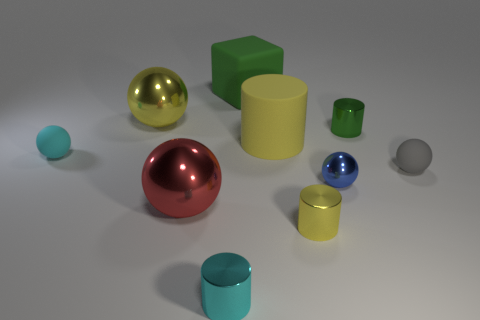How many other things are the same material as the small blue object?
Ensure brevity in your answer.  5. Does the large rubber cylinder have the same color as the rubber block?
Provide a succinct answer. No. Are there fewer yellow matte cylinders that are on the left side of the big yellow matte cylinder than cyan things that are behind the small cyan metallic cylinder?
Your response must be concise. Yes. What color is the other matte thing that is the same shape as the small green object?
Provide a succinct answer. Yellow. Do the matte ball that is right of the blue ball and the tiny yellow object have the same size?
Your response must be concise. Yes. Is the number of big green things that are in front of the large red sphere less than the number of green cubes?
Your answer should be very brief. Yes. What size is the shiny thing behind the tiny green metal thing behind the tiny yellow cylinder?
Ensure brevity in your answer.  Large. Is there anything else that has the same shape as the blue metal thing?
Ensure brevity in your answer.  Yes. Are there fewer large balls than rubber objects?
Offer a terse response. Yes. There is a object that is both behind the small cyan rubber thing and on the left side of the red metallic sphere; what material is it made of?
Offer a very short reply. Metal. 